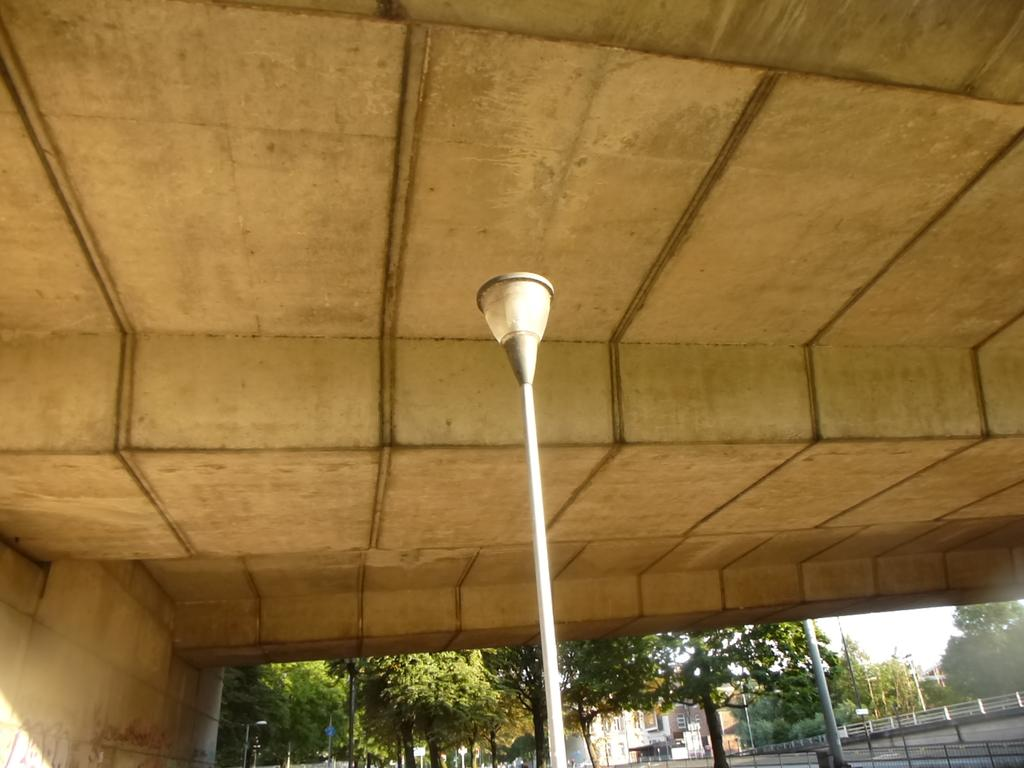What type of pathway can be seen in the image? There is a road in the image. What natural elements are present in the image? There are trees in the image. What man-made structures are visible in the image? There are buildings and a light pole in the image. What type of elevated structure is visible in the image? The roof of a flyover is visible in the image. What type of music can be heard coming from the buildings in the image? There is no indication of music or any sounds in the image, so it's not possible to determine what, if any, music might be heard. 